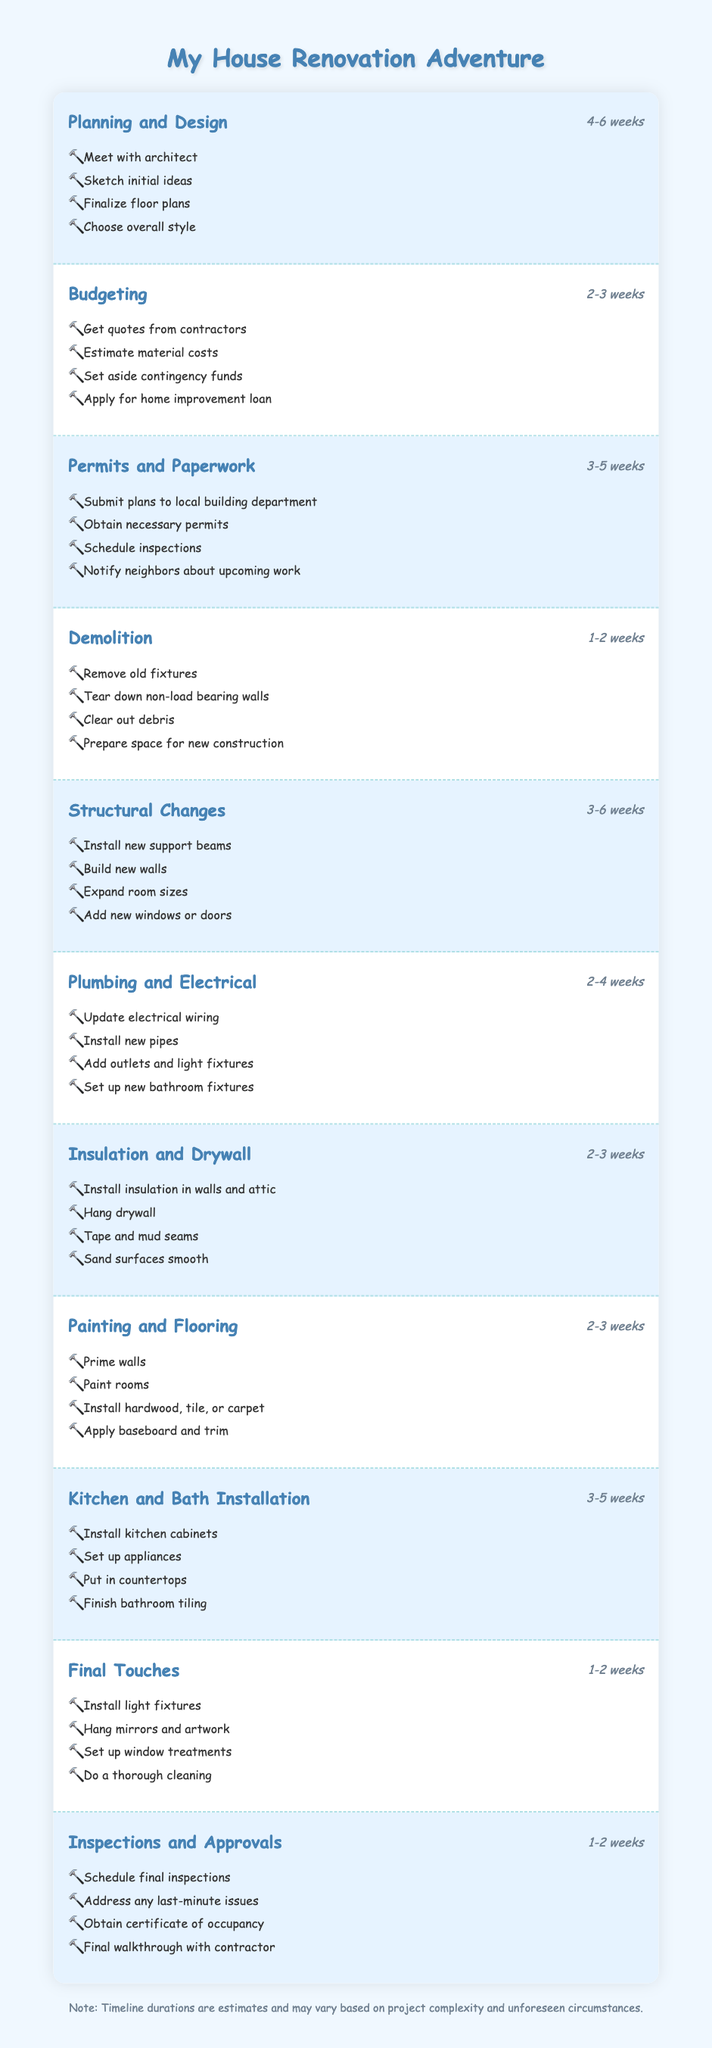What is the duration of the "Planning and Design" stage? The table lists "Planning and Design" as having a duration of "4-6 weeks." There is no need for additional calculations since the information is explicitly stated.
Answer: 4-6 weeks How many tasks are involved in the "Budgeting" stage? The "Budgeting" stage contains four tasks: getting quotes from contractors, estimating material costs, setting aside contingency funds, and applying for a home improvement loan. The count is derived directly from the list of tasks provided.
Answer: 4 Which stage has the longest possible duration, and what is that duration? When assessing the durations, "Structural Changes" has a range of "3-6 weeks," which is the longest duration range among all stages. This is determined by comparing the maximum potential duration for each stage listed in the table.
Answer: Structural Changes, 3-6 weeks Is it true that "Final Touches" takes longer than "Demolition"? The "Final Touches" stage has a duration of "1-2 weeks," while the "Demolition" stage also has a duration of "1-2 weeks." Since their durations overlap and are equal, the statement is false.
Answer: No What is the total duration range for the stages that fall under "Plumbing and Electrical" and "Kitchen and Bath Installation"? "Plumbing and Electrical" ranges from "2-4 weeks," and "Kitchen and Bath Installation" ranges from "3-5 weeks." To find the overall coverage, you take the lowest overall start, which is 2 weeks (from "Plumbing and Electrical"), and the highest end is 5 weeks (from "Kitchen and Bath Installation"). Thus, the total duration range is "2-5 weeks."
Answer: 2-5 weeks Which stages require permits, and how long are they estimated to take? The stages that require permits are "Permits and Paperwork," which takes "3-5 weeks." No other stage in the timeline explicitly mentions permits, so we can conclude that this is the only one requiring them.
Answer: Permits and Paperwork, 3-5 weeks What is the median duration of all the stages? To find the median, first, we compile a list of durations in weeks: [4-6, 2-3, 3-5, 1-2, 3-6, 2-4, 2-3, 2-3, 3-5, 1-2, 1-2]. This requires converting ranges into numerical values, resulting in values of (5, 2.5, 4, 1.5, 4.5, 3, 2.5, 2.5, 4, 1.5, 1.5). After sorting them, the middle values would show 2.5, and 4. Consequently, we average them to get the median duration, which is "2.5-4 weeks."
Answer: 2.5-4 weeks How many total tasks are involved across the entire project? By summing the tasks listed for each stage, we find: 4 (Planning) + 4 (Budgeting) + 4 (Permits) + 4 (Demolition) + 4 (Structural Changes) + 4 (Plumbing) + 4 (Insulation) + 4 (Painting) + 4 (Kitchen and Bath) + 4 (Final Touches) + 4 (Inspections) = 44 total tasks across all stages.
Answer: 44 tasks 